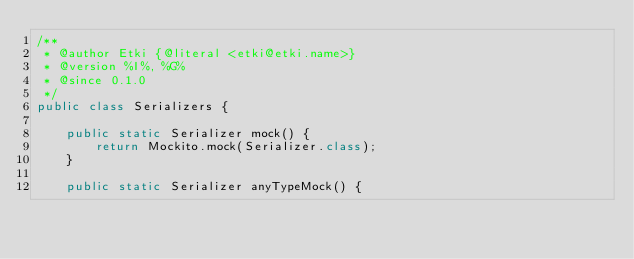<code> <loc_0><loc_0><loc_500><loc_500><_Java_>/**
 * @author Etki {@literal <etki@etki.name>}
 * @version %I%, %G%
 * @since 0.1.0
 */
public class Serializers {

    public static Serializer mock() {
        return Mockito.mock(Serializer.class);
    }

    public static Serializer anyTypeMock() {</code> 